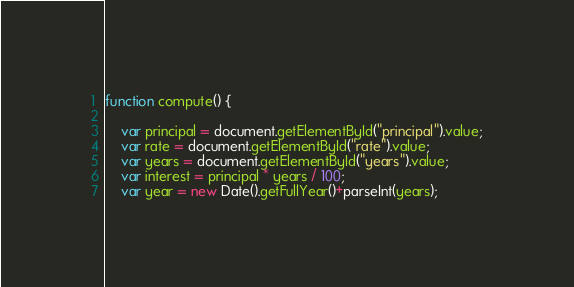Convert code to text. <code><loc_0><loc_0><loc_500><loc_500><_JavaScript_>
function compute() {

    var principal = document.getElementById("principal").value;
    var rate = document.getElementById("rate").value;
    var years = document.getElementById("years").value;
    var interest = principal * years / 100;
    var year = new Date().getFullYear()+parseInt(years);
</code> 